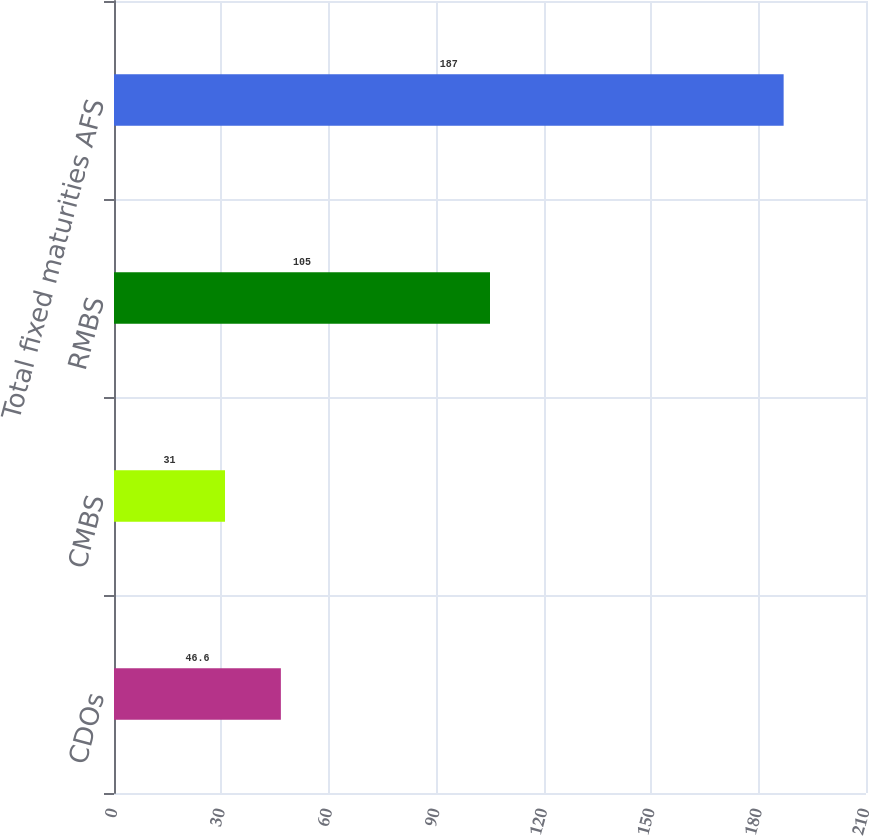Convert chart. <chart><loc_0><loc_0><loc_500><loc_500><bar_chart><fcel>CDOs<fcel>CMBS<fcel>RMBS<fcel>Total fixed maturities AFS<nl><fcel>46.6<fcel>31<fcel>105<fcel>187<nl></chart> 